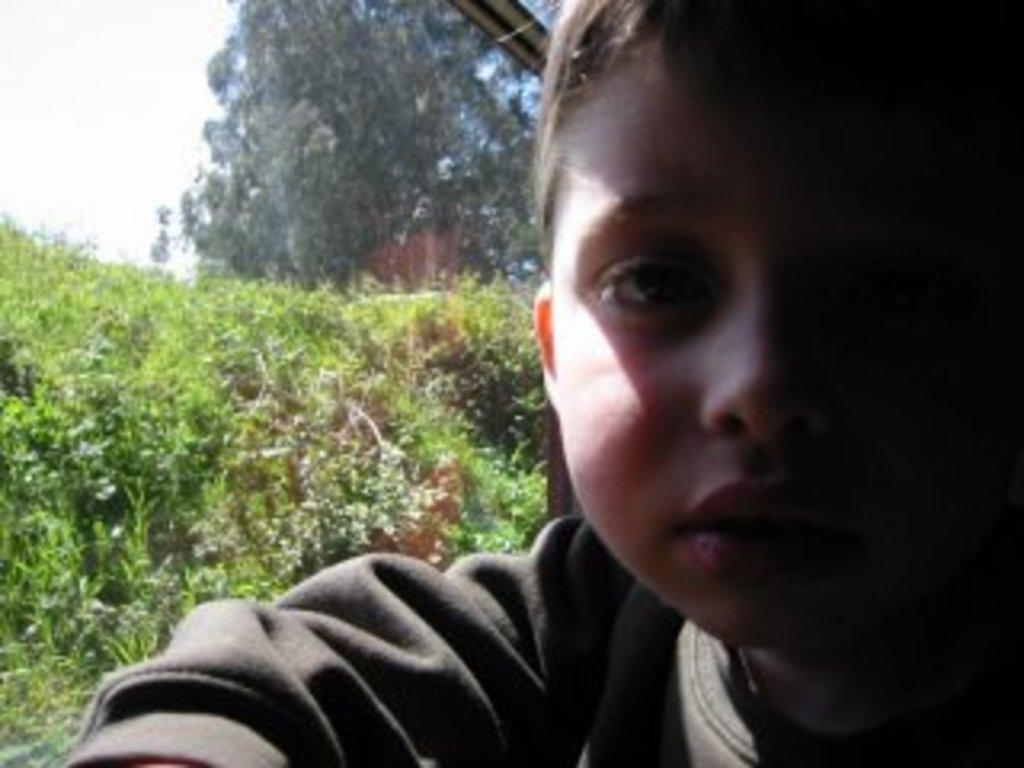Who is the main subject in the image? There is a boy in the image. What can be seen on the left side of the image? There are plants on the left side of the image. What is visible at the top of the image? There is a tree visible at the top of the image. What is visible in the background of the image? The sky is visible in the image. What type of coil is the boy using to communicate with his friend in the image? There is no coil or communication device visible in the image, and no friend is mentioned. 